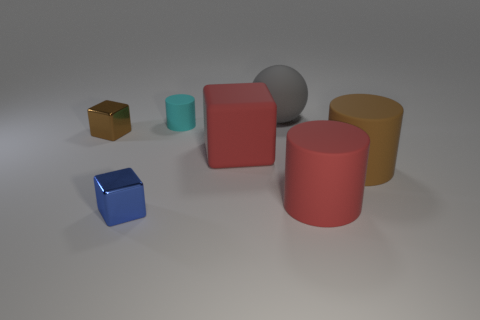Add 2 big gray spheres. How many objects exist? 9 Subtract all cylinders. How many objects are left? 4 Subtract 0 blue cylinders. How many objects are left? 7 Subtract all blue objects. Subtract all big red blocks. How many objects are left? 5 Add 6 large rubber cylinders. How many large rubber cylinders are left? 8 Add 4 tiny cylinders. How many tiny cylinders exist? 5 